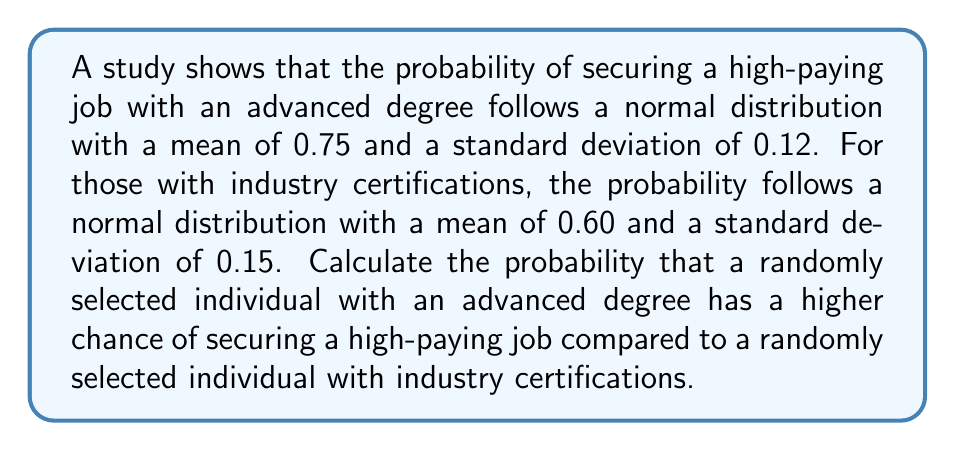Teach me how to tackle this problem. To solve this problem, we need to find the probability that the difference between the two normally distributed random variables is greater than zero. Let's approach this step-by-step:

1) Let X be the probability for an individual with an advanced degree:
   $X \sim N(\mu_X = 0.75, \sigma_X = 0.12)$

2) Let Y be the probability for an individual with industry certifications:
   $Y \sim N(\mu_Y = 0.60, \sigma_Y = 0.15)$

3) We want to find $P(X > Y)$, which is equivalent to $P(X - Y > 0)$

4) The difference of two normally distributed random variables is also normally distributed:
   $X - Y \sim N(\mu_{X-Y}, \sigma_{X-Y})$

5) The mean of the difference:
   $\mu_{X-Y} = \mu_X - \mu_Y = 0.75 - 0.60 = 0.15$

6) The variance of the difference:
   $\sigma_{X-Y}^2 = \sigma_X^2 + \sigma_Y^2 = 0.12^2 + 0.15^2 = 0.0369$

7) The standard deviation of the difference:
   $\sigma_{X-Y} = \sqrt{0.0369} \approx 0.1921$

8) Now, we need to find $P(X - Y > 0)$, which is equivalent to finding the area to the right of 0 under the normal distribution $N(0.15, 0.1921)$

9) We can standardize this to a Z-score:
   $Z = \frac{0 - 0.15}{0.1921} \approx -0.7808$

10) Using a standard normal distribution table or calculator, we find:
    $P(Z > -0.7808) \approx 0.7825$

Therefore, the probability that an individual with an advanced degree has a higher chance of securing a high-paying job compared to an individual with industry certifications is approximately 0.7825 or 78.25%.
Answer: 0.7825 